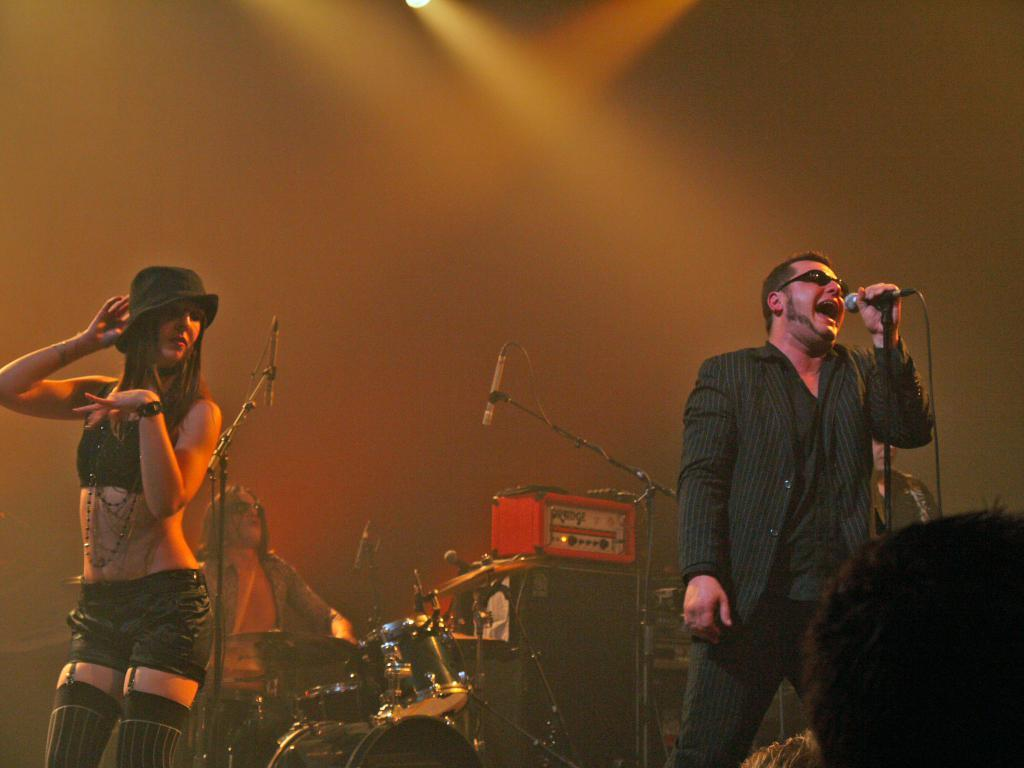What is the man in the image doing? The man is singing in the image. How is the man holding the microphone? The man is holding the microphone with his left hand. What is the woman in the image doing? The woman is standing in the image. Can you describe the person in the background of the image? The person in the background is sitting at a drum set. What type of shelf can be seen in the image? There is no shelf present in the image. What edge is the man standing on in the image? The man is not standing on an edge in the image; he is singing with a microphone. 